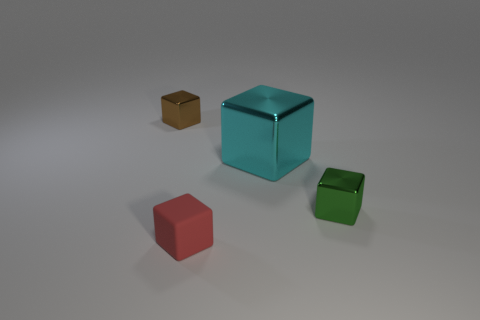Subtract all cyan blocks. How many blocks are left? 3 Subtract 1 cubes. How many cubes are left? 3 Subtract all brown cubes. How many cubes are left? 3 Add 4 small things. How many objects exist? 8 Subtract 0 purple cylinders. How many objects are left? 4 Subtract all purple cubes. Subtract all green spheres. How many cubes are left? 4 Subtract all cyan shiny objects. Subtract all red rubber cubes. How many objects are left? 2 Add 4 small red objects. How many small red objects are left? 5 Add 2 cyan shiny spheres. How many cyan shiny spheres exist? 2 